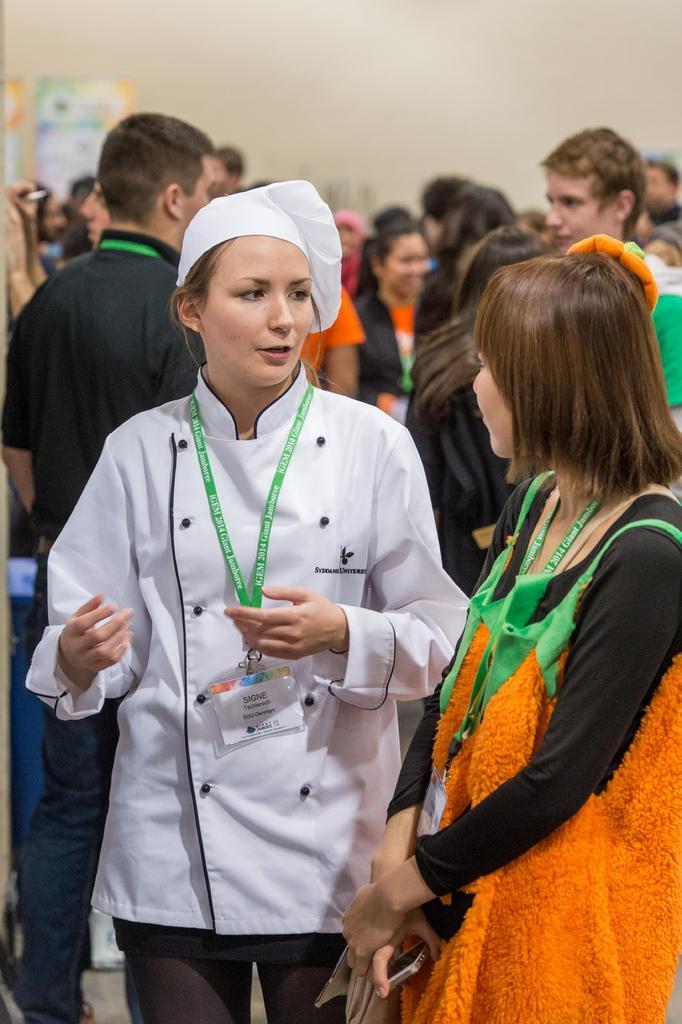Describe this image in one or two sentences. In the picture we can see two women are standing and talking and they are in green color tags with Id cards and behind them, we can see many people are standing and talking to each other and in the background we can see the wall with a poster to it. 